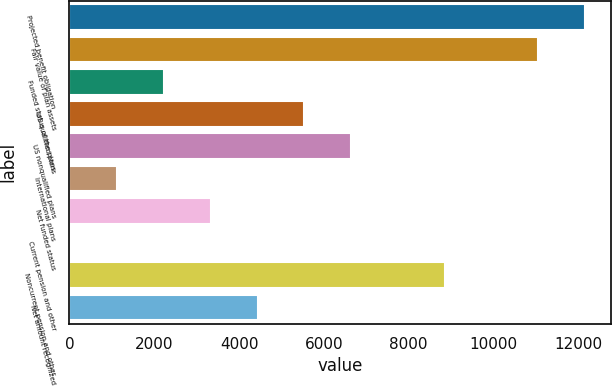Convert chart. <chart><loc_0><loc_0><loc_500><loc_500><bar_chart><fcel>Projected benefit obligation<fcel>Fair value of plan assets<fcel>Funded status of the plans<fcel>US qualified plans<fcel>US nonqualified plans<fcel>International plans<fcel>Net funded status<fcel>Current pension and other<fcel>Noncurrent pension and other<fcel>Net amount recognized<nl><fcel>12151.9<fcel>11050<fcel>2234.8<fcel>5540.5<fcel>6642.4<fcel>1132.9<fcel>3336.7<fcel>31<fcel>8846.2<fcel>4438.6<nl></chart> 